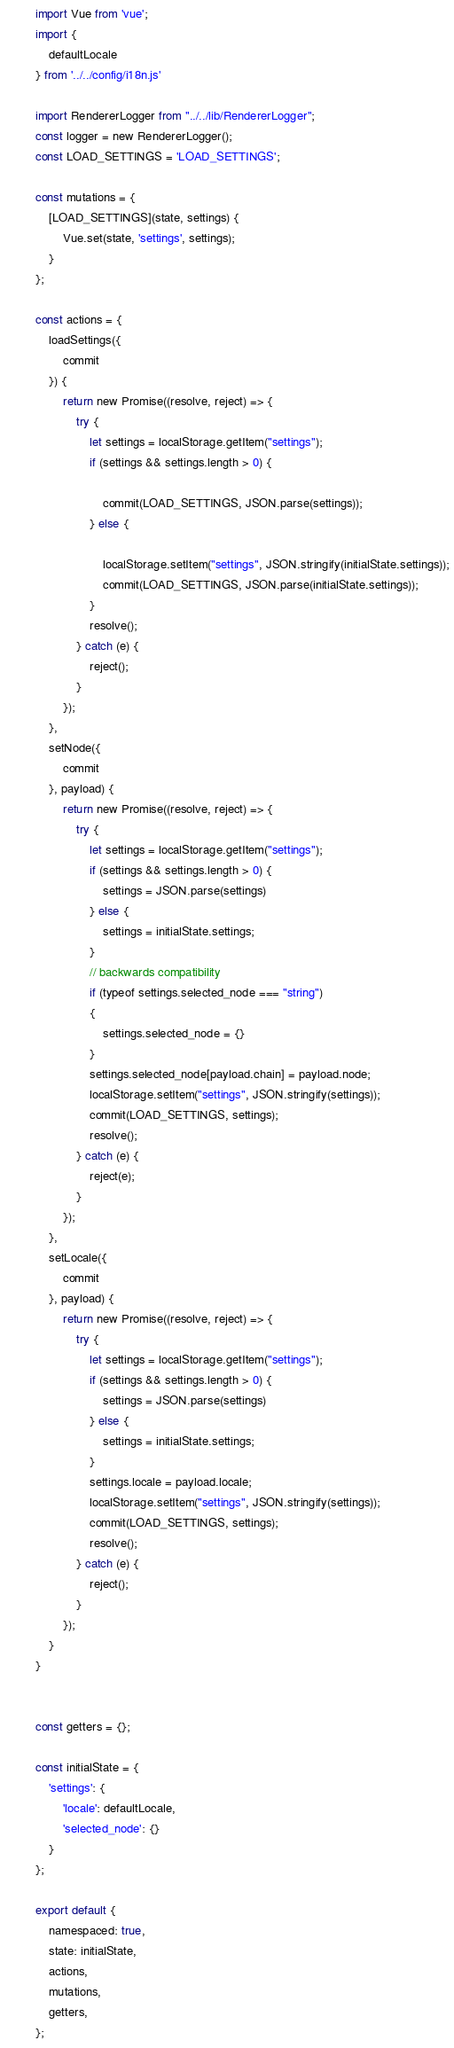<code> <loc_0><loc_0><loc_500><loc_500><_JavaScript_>import Vue from 'vue';
import {
    defaultLocale
} from '../../config/i18n.js'

import RendererLogger from "../../lib/RendererLogger";
const logger = new RendererLogger();
const LOAD_SETTINGS = 'LOAD_SETTINGS';

const mutations = {
    [LOAD_SETTINGS](state, settings) {
        Vue.set(state, 'settings', settings);
    }
};

const actions = {
    loadSettings({
        commit
    }) {
        return new Promise((resolve, reject) => {
            try {
                let settings = localStorage.getItem("settings");
                if (settings && settings.length > 0) {

                    commit(LOAD_SETTINGS, JSON.parse(settings));
                } else {

                    localStorage.setItem("settings", JSON.stringify(initialState.settings));
                    commit(LOAD_SETTINGS, JSON.parse(initialState.settings));
                }
                resolve();
            } catch (e) {
                reject();
            }
        });
    },
    setNode({
        commit
    }, payload) {
        return new Promise((resolve, reject) => {
            try {
                let settings = localStorage.getItem("settings");
                if (settings && settings.length > 0) {
                    settings = JSON.parse(settings)
                } else {
                    settings = initialState.settings;
                }
                // backwards compatibility
                if (typeof settings.selected_node === "string")
                {
                    settings.selected_node = {}
                }
                settings.selected_node[payload.chain] = payload.node;
                localStorage.setItem("settings", JSON.stringify(settings));
                commit(LOAD_SETTINGS, settings);
                resolve();
            } catch (e) {
                reject(e);
            }
        });
    },
    setLocale({
        commit
    }, payload) {
        return new Promise((resolve, reject) => {
            try {
                let settings = localStorage.getItem("settings");
                if (settings && settings.length > 0) {
                    settings = JSON.parse(settings)
                } else {
                    settings = initialState.settings;
                }
                settings.locale = payload.locale;
                localStorage.setItem("settings", JSON.stringify(settings));
                commit(LOAD_SETTINGS, settings);
                resolve();
            } catch (e) {
                reject();
            }
        });
    }
}


const getters = {};

const initialState = {
    'settings': {
        'locale': defaultLocale,
        'selected_node': {}
    }
};

export default {
    namespaced: true,
    state: initialState,
    actions,
    mutations,
    getters,
};</code> 